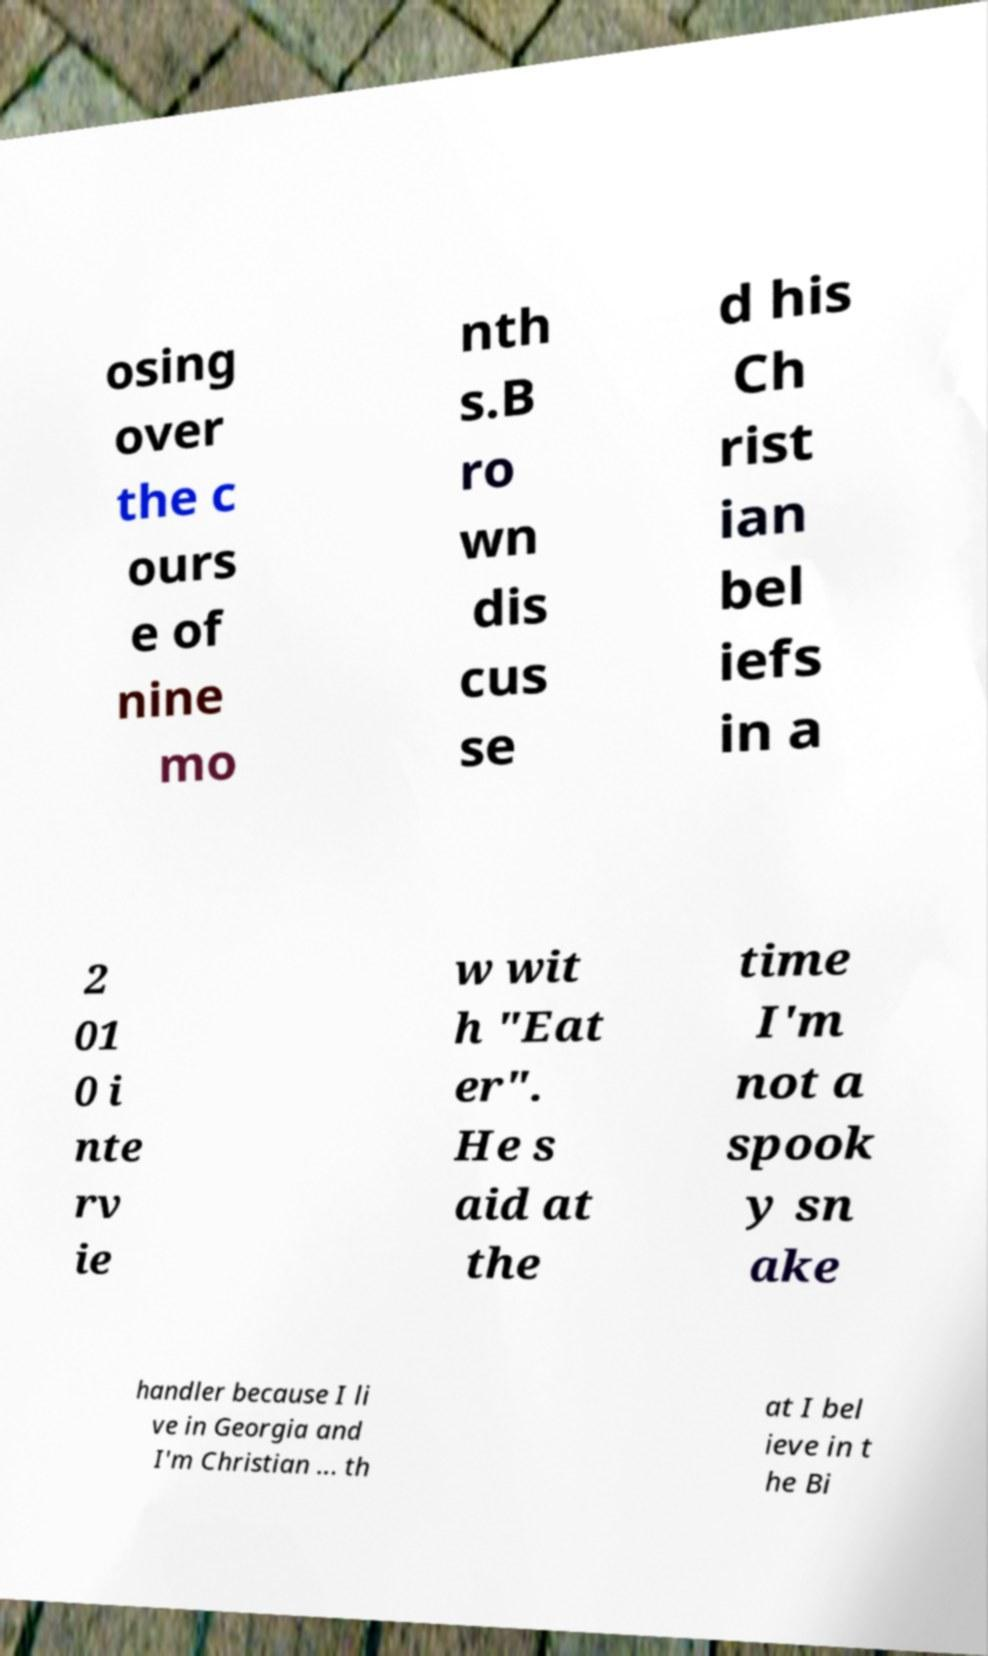Can you accurately transcribe the text from the provided image for me? osing over the c ours e of nine mo nth s.B ro wn dis cus se d his Ch rist ian bel iefs in a 2 01 0 i nte rv ie w wit h "Eat er". He s aid at the time I'm not a spook y sn ake handler because I li ve in Georgia and I'm Christian ... th at I bel ieve in t he Bi 